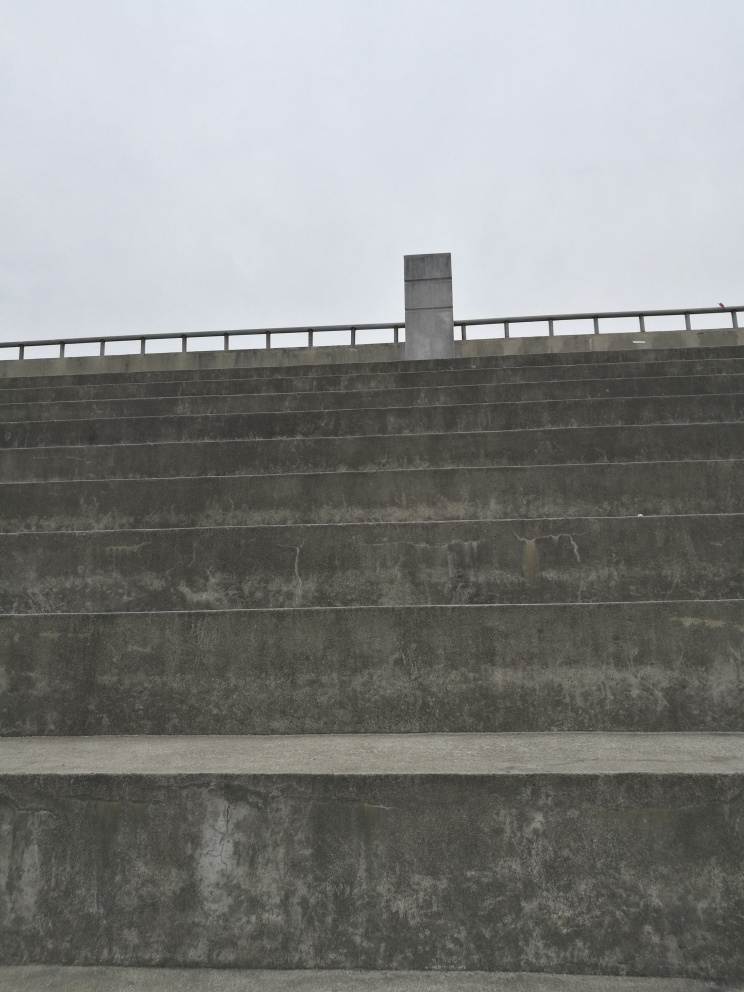Can you hypothesize about the location or the function of the structure depicted in the image? Based on the image, we see a solid, utilitarian structure that could be part of a larger industrial or transportation facility, perhaps a bridge abutment or a retaining wall. The handrail at the top implies that there may be a walkway or a platform for observation or maintenance purposes. 